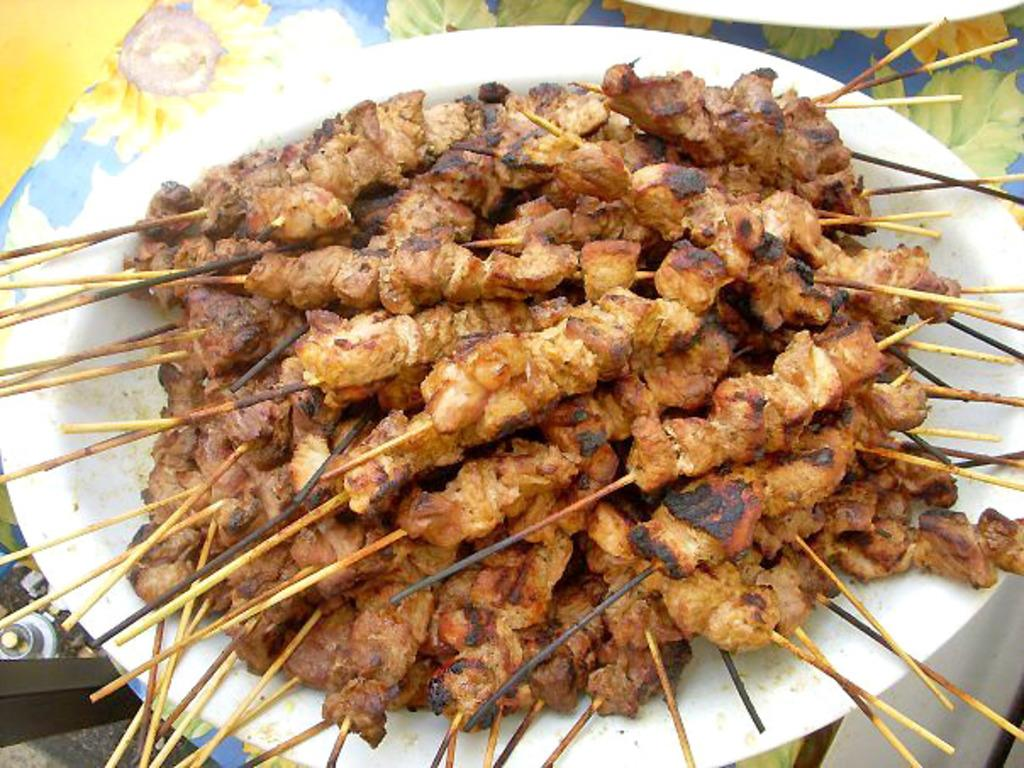What type of food can be seen in the image? There is grilled food with sticks in the image. How is the grilled food arranged or presented? The grilled food is placed on a plate. What is the plate resting on in the image? The plate is on a flowered mat. What type of bean is being observed by the boy in the image? There is no boy or bean present in the image; it features grilled food with sticks on a plate resting on a flowered mat. 